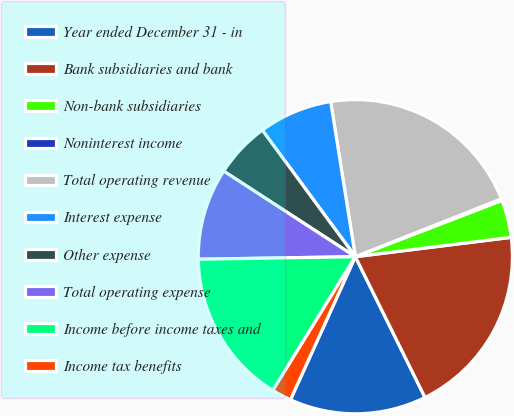Convert chart to OTSL. <chart><loc_0><loc_0><loc_500><loc_500><pie_chart><fcel>Year ended December 31 - in<fcel>Bank subsidiaries and bank<fcel>Non-bank subsidiaries<fcel>Noninterest income<fcel>Total operating revenue<fcel>Interest expense<fcel>Other expense<fcel>Total operating expense<fcel>Income before income taxes and<fcel>Income tax benefits<nl><fcel>14.09%<fcel>19.65%<fcel>3.87%<fcel>0.17%<fcel>21.5%<fcel>7.58%<fcel>5.73%<fcel>9.43%<fcel>15.94%<fcel>2.02%<nl></chart> 